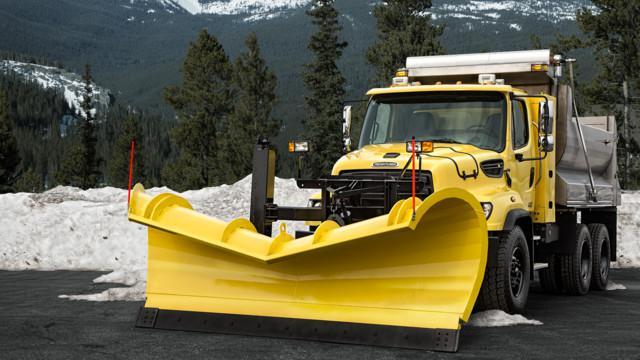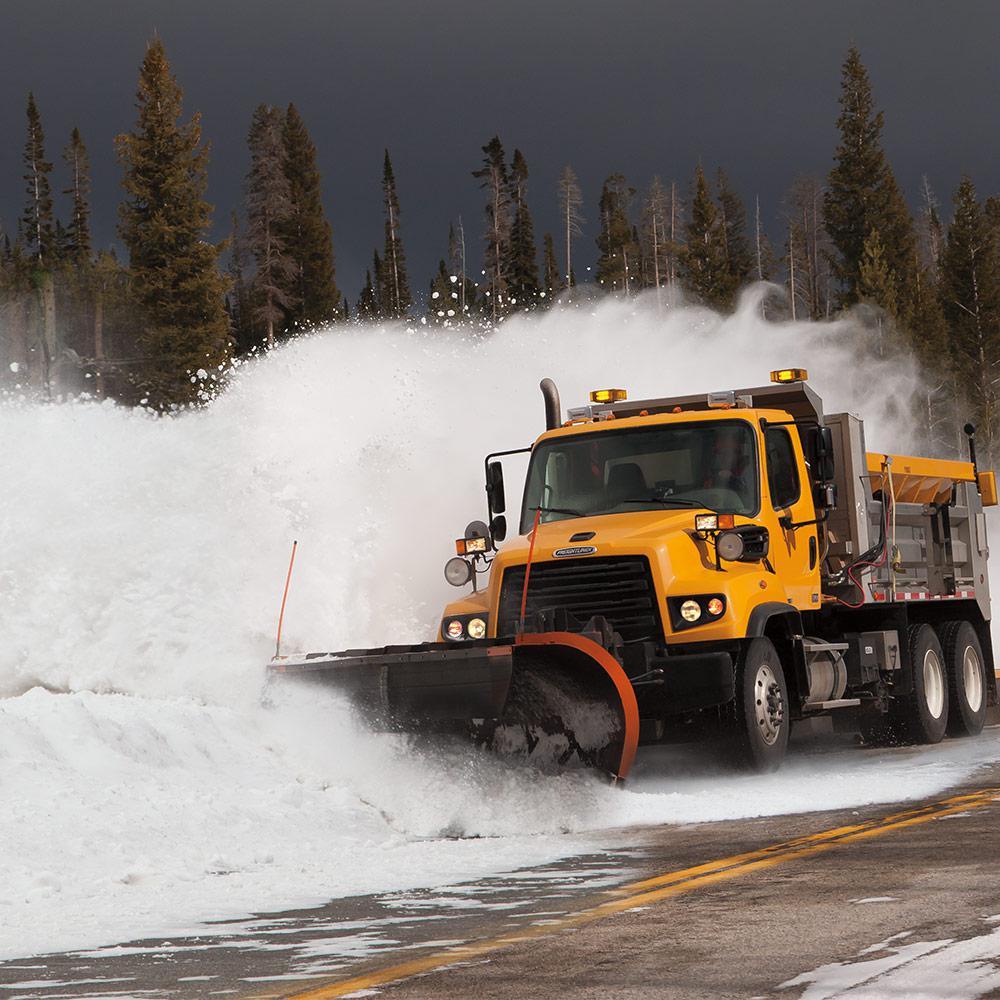The first image is the image on the left, the second image is the image on the right. Assess this claim about the two images: "There is at least one blue truck in the images.". Correct or not? Answer yes or no. No. 